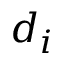<formula> <loc_0><loc_0><loc_500><loc_500>d _ { i }</formula> 